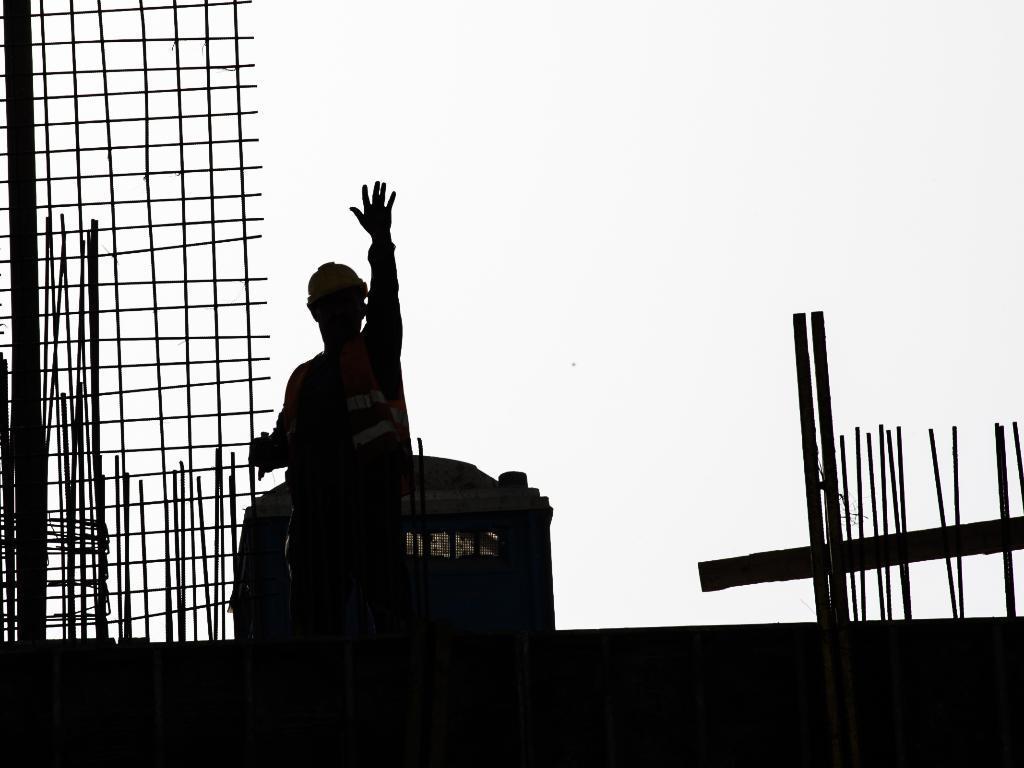Describe this image in one or two sentences. In this picture I see a person in front and in the background I see the rods and I see the sky and I see that this image is a bit dark. 